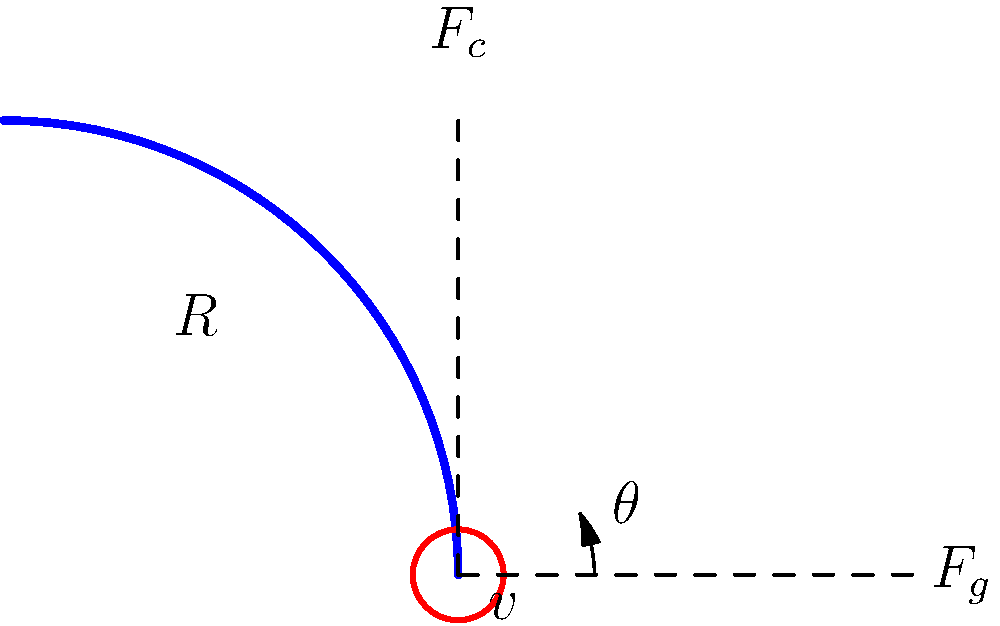As an IMSA SportsCar Championship enthusiast, you're analyzing the Daytona International Speedway's banked turns. For a specific turn with a radius of 200 meters, calculate the optimal banking angle $\theta$ for a car traveling at 180 km/h (50 m/s). Assume the coefficient of friction between the tires and the track is 0.8 and acceleration due to gravity is 9.8 m/s². What is the optimal banking angle in degrees? Let's approach this step-by-step:

1) First, we need to understand the forces acting on the car:
   - Centripetal force required: $F_c = \frac{mv^2}{R}$
   - Gravity: $F_g = mg$

2) For the optimal banking angle, we want the normal force from the track to provide all the centripetal force without relying on friction. This occurs when:

   $\tan \theta = \frac{v^2}{gR}$

3) Let's plug in our values:
   $v = 50$ m/s
   $g = 9.8$ m/s²
   $R = 200$ m

4) Now we can calculate:

   $\tan \theta = \frac{50^2}{9.8 \times 200} = \frac{2500}{1960} = 1.2755$

5) To get the angle in degrees, we need to take the inverse tangent (arctan) and convert to degrees:

   $\theta = \arctan(1.2755) \times \frac{180}{\pi} = 51.84°$

Therefore, the optimal banking angle is approximately 51.84 degrees.
Answer: 51.84° 